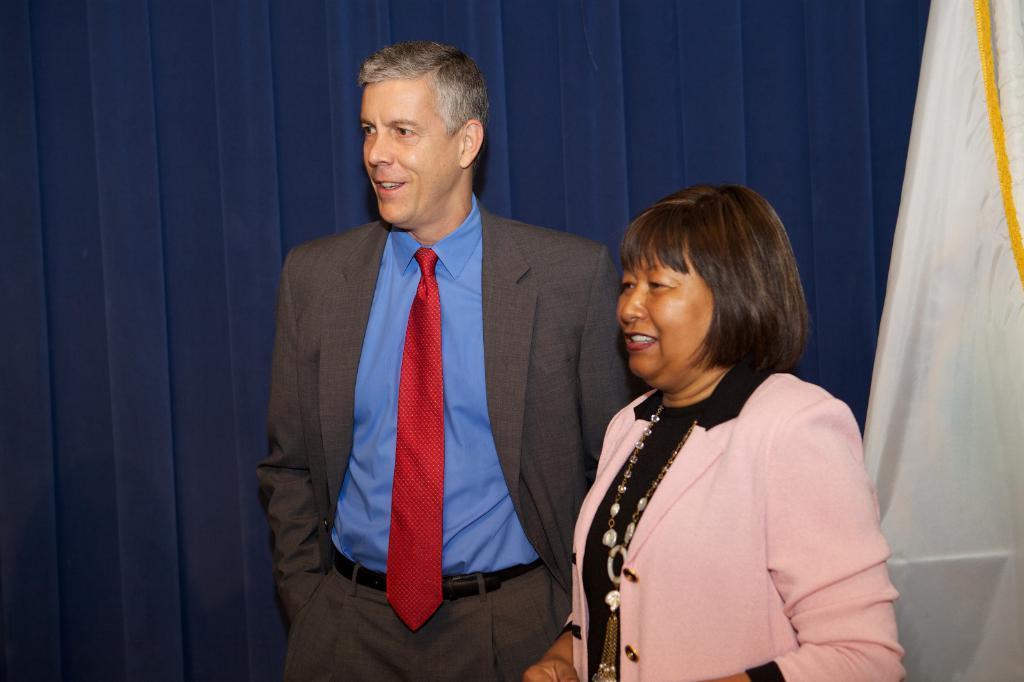Could you give a brief overview of what you see in this image? In this image there are two people standing with a smile on their face. In the background there is like a curtain and a flag. 